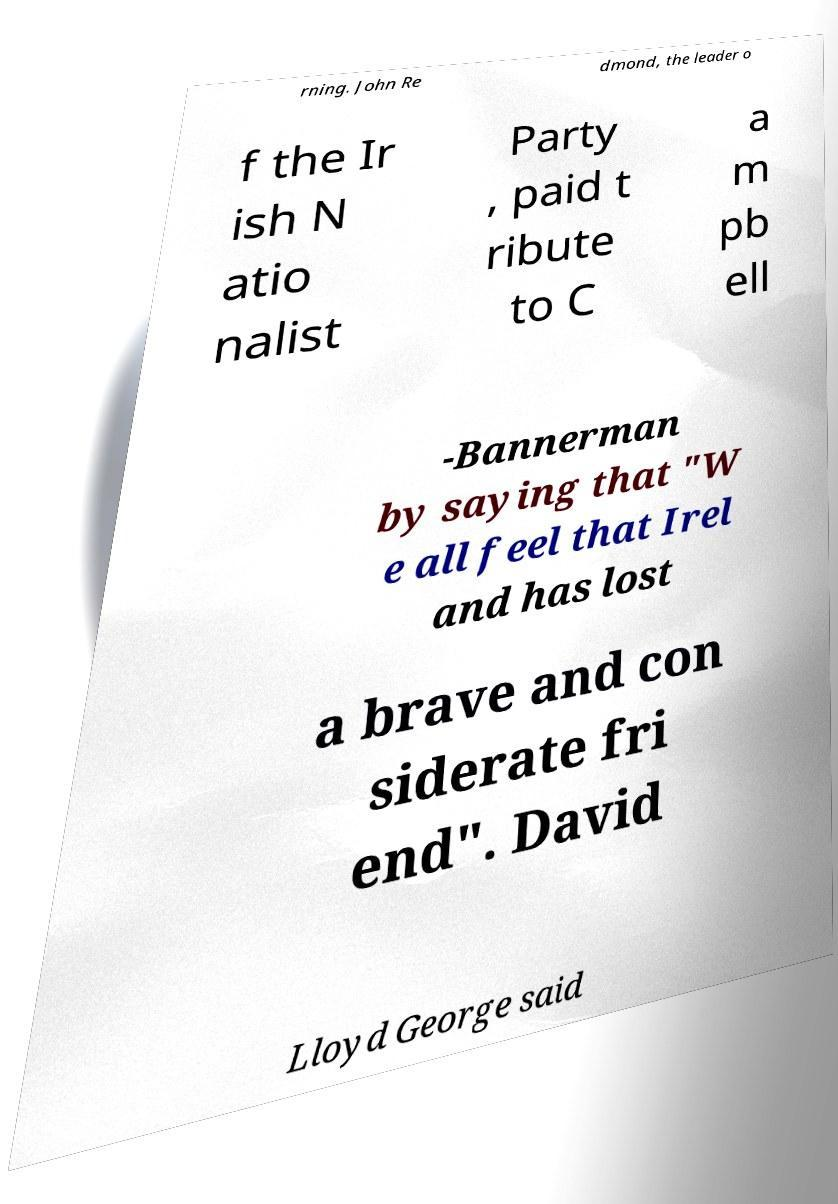Can you accurately transcribe the text from the provided image for me? rning. John Re dmond, the leader o f the Ir ish N atio nalist Party , paid t ribute to C a m pb ell -Bannerman by saying that "W e all feel that Irel and has lost a brave and con siderate fri end". David Lloyd George said 